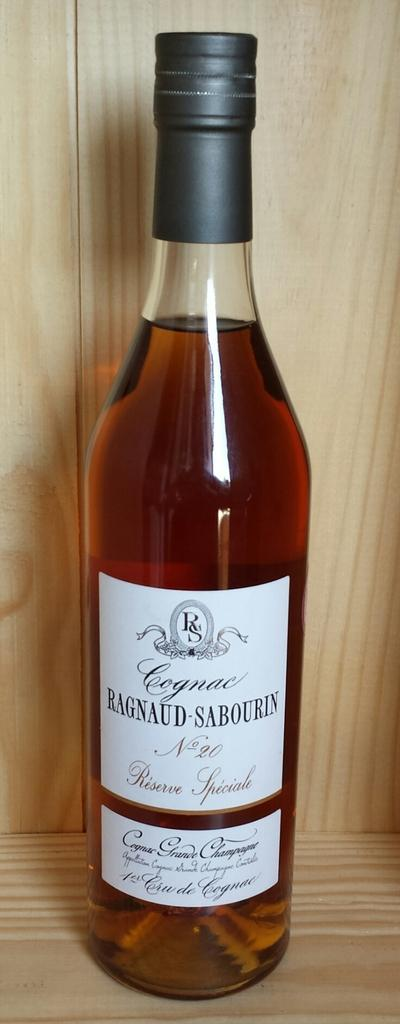<image>
Summarize the visual content of the image. A clear slender bottle of cognac is on a wooden shelf. 